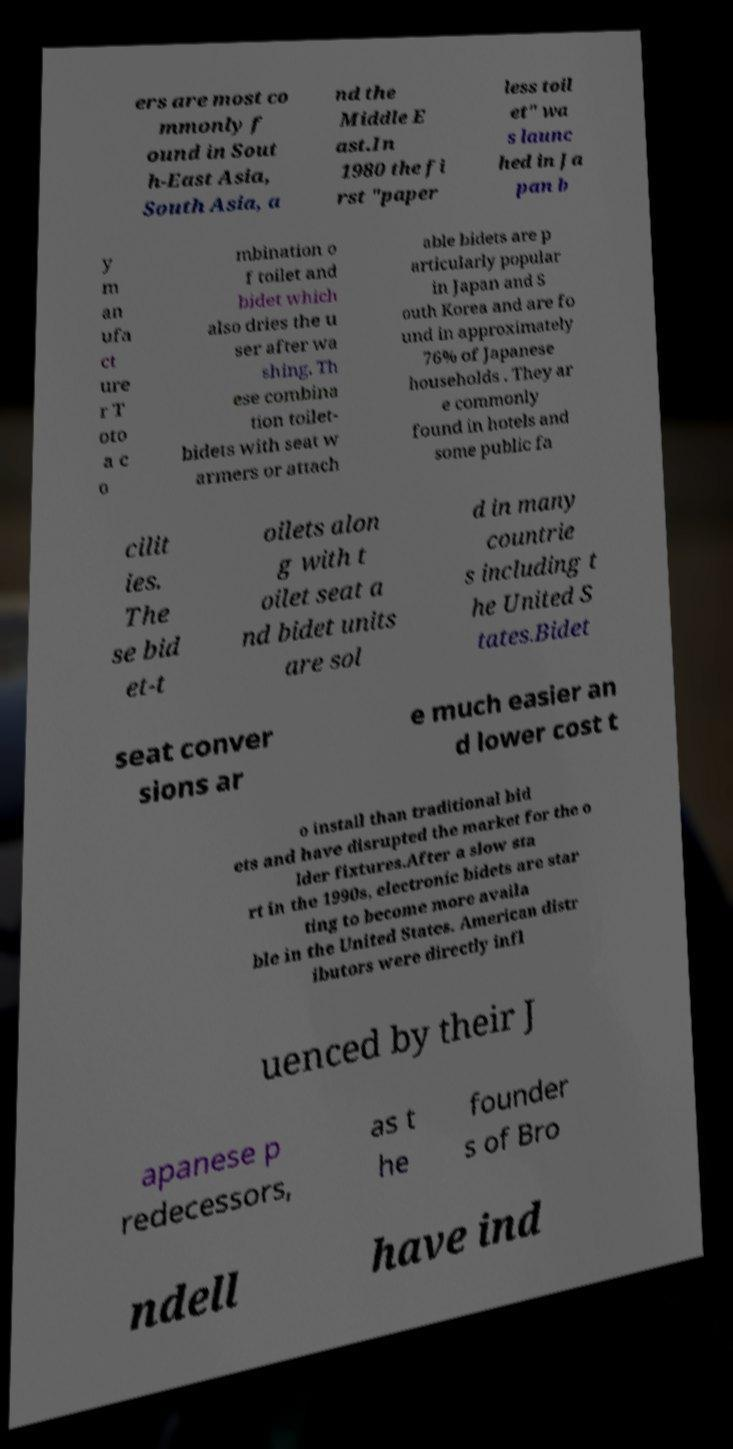Could you extract and type out the text from this image? ers are most co mmonly f ound in Sout h-East Asia, South Asia, a nd the Middle E ast.In 1980 the fi rst "paper less toil et" wa s launc hed in Ja pan b y m an ufa ct ure r T oto a c o mbination o f toilet and bidet which also dries the u ser after wa shing. Th ese combina tion toilet- bidets with seat w armers or attach able bidets are p articularly popular in Japan and S outh Korea and are fo und in approximately 76% of Japanese households . They ar e commonly found in hotels and some public fa cilit ies. The se bid et-t oilets alon g with t oilet seat a nd bidet units are sol d in many countrie s including t he United S tates.Bidet seat conver sions ar e much easier an d lower cost t o install than traditional bid ets and have disrupted the market for the o lder fixtures.After a slow sta rt in the 1990s, electronic bidets are star ting to become more availa ble in the United States. American distr ibutors were directly infl uenced by their J apanese p redecessors, as t he founder s of Bro ndell have ind 